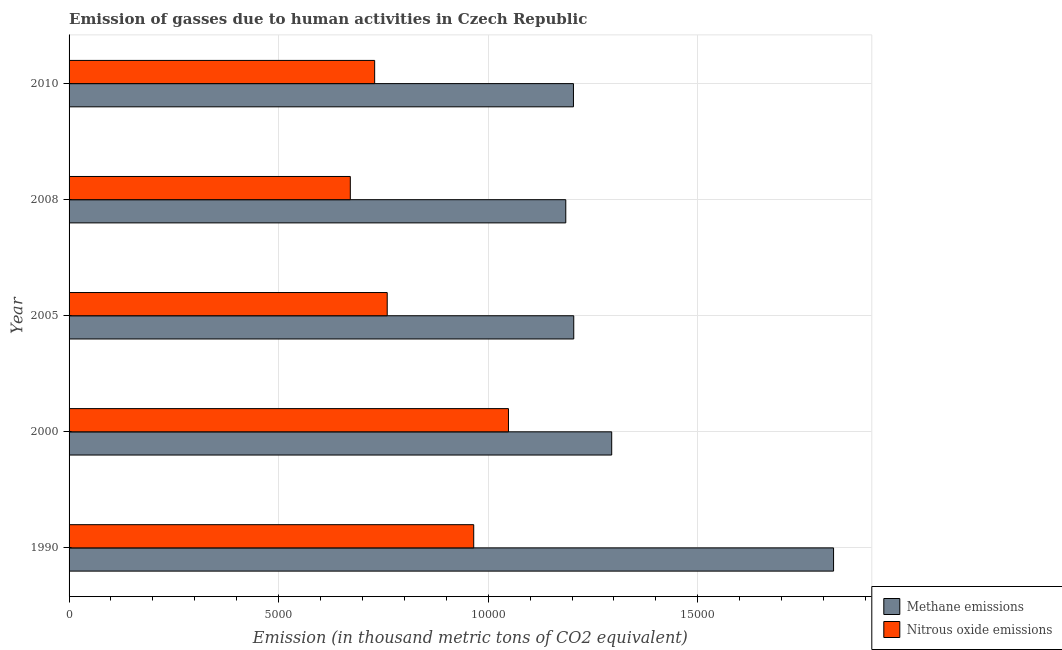Are the number of bars per tick equal to the number of legend labels?
Your answer should be compact. Yes. How many bars are there on the 1st tick from the bottom?
Give a very brief answer. 2. In how many cases, is the number of bars for a given year not equal to the number of legend labels?
Offer a very short reply. 0. What is the amount of nitrous oxide emissions in 2000?
Keep it short and to the point. 1.05e+04. Across all years, what is the maximum amount of methane emissions?
Give a very brief answer. 1.82e+04. Across all years, what is the minimum amount of methane emissions?
Offer a very short reply. 1.19e+04. In which year was the amount of methane emissions maximum?
Ensure brevity in your answer.  1990. What is the total amount of nitrous oxide emissions in the graph?
Provide a short and direct response. 4.17e+04. What is the difference between the amount of nitrous oxide emissions in 1990 and that in 2005?
Your answer should be compact. 2063.7. What is the difference between the amount of methane emissions in 2008 and the amount of nitrous oxide emissions in 2010?
Provide a short and direct response. 4559.9. What is the average amount of methane emissions per year?
Your answer should be very brief. 1.34e+04. In the year 2010, what is the difference between the amount of methane emissions and amount of nitrous oxide emissions?
Your answer should be compact. 4742.9. What is the ratio of the amount of methane emissions in 1990 to that in 2010?
Provide a short and direct response. 1.52. Is the amount of nitrous oxide emissions in 2005 less than that in 2008?
Your response must be concise. No. What is the difference between the highest and the second highest amount of methane emissions?
Provide a succinct answer. 5293.1. What is the difference between the highest and the lowest amount of methane emissions?
Provide a short and direct response. 6388.9. In how many years, is the amount of methane emissions greater than the average amount of methane emissions taken over all years?
Give a very brief answer. 1. Is the sum of the amount of methane emissions in 2000 and 2005 greater than the maximum amount of nitrous oxide emissions across all years?
Your answer should be very brief. Yes. What does the 1st bar from the top in 2005 represents?
Your answer should be very brief. Nitrous oxide emissions. What does the 2nd bar from the bottom in 2005 represents?
Offer a terse response. Nitrous oxide emissions. How many bars are there?
Ensure brevity in your answer.  10. Are all the bars in the graph horizontal?
Your answer should be compact. Yes. Does the graph contain any zero values?
Your answer should be very brief. No. Does the graph contain grids?
Give a very brief answer. Yes. How many legend labels are there?
Keep it short and to the point. 2. What is the title of the graph?
Offer a very short reply. Emission of gasses due to human activities in Czech Republic. What is the label or title of the X-axis?
Your answer should be compact. Emission (in thousand metric tons of CO2 equivalent). What is the Emission (in thousand metric tons of CO2 equivalent) of Methane emissions in 1990?
Give a very brief answer. 1.82e+04. What is the Emission (in thousand metric tons of CO2 equivalent) in Nitrous oxide emissions in 1990?
Give a very brief answer. 9654. What is the Emission (in thousand metric tons of CO2 equivalent) in Methane emissions in 2000?
Your answer should be compact. 1.29e+04. What is the Emission (in thousand metric tons of CO2 equivalent) in Nitrous oxide emissions in 2000?
Offer a very short reply. 1.05e+04. What is the Emission (in thousand metric tons of CO2 equivalent) of Methane emissions in 2005?
Offer a very short reply. 1.20e+04. What is the Emission (in thousand metric tons of CO2 equivalent) in Nitrous oxide emissions in 2005?
Provide a succinct answer. 7590.3. What is the Emission (in thousand metric tons of CO2 equivalent) of Methane emissions in 2008?
Keep it short and to the point. 1.19e+04. What is the Emission (in thousand metric tons of CO2 equivalent) of Nitrous oxide emissions in 2008?
Offer a terse response. 6709.7. What is the Emission (in thousand metric tons of CO2 equivalent) in Methane emissions in 2010?
Offer a terse response. 1.20e+04. What is the Emission (in thousand metric tons of CO2 equivalent) of Nitrous oxide emissions in 2010?
Offer a very short reply. 7290.5. Across all years, what is the maximum Emission (in thousand metric tons of CO2 equivalent) of Methane emissions?
Provide a succinct answer. 1.82e+04. Across all years, what is the maximum Emission (in thousand metric tons of CO2 equivalent) of Nitrous oxide emissions?
Keep it short and to the point. 1.05e+04. Across all years, what is the minimum Emission (in thousand metric tons of CO2 equivalent) of Methane emissions?
Provide a succinct answer. 1.19e+04. Across all years, what is the minimum Emission (in thousand metric tons of CO2 equivalent) in Nitrous oxide emissions?
Provide a short and direct response. 6709.7. What is the total Emission (in thousand metric tons of CO2 equivalent) in Methane emissions in the graph?
Your answer should be very brief. 6.71e+04. What is the total Emission (in thousand metric tons of CO2 equivalent) in Nitrous oxide emissions in the graph?
Make the answer very short. 4.17e+04. What is the difference between the Emission (in thousand metric tons of CO2 equivalent) in Methane emissions in 1990 and that in 2000?
Make the answer very short. 5293.1. What is the difference between the Emission (in thousand metric tons of CO2 equivalent) of Nitrous oxide emissions in 1990 and that in 2000?
Keep it short and to the point. -829. What is the difference between the Emission (in thousand metric tons of CO2 equivalent) in Methane emissions in 1990 and that in 2005?
Give a very brief answer. 6198.5. What is the difference between the Emission (in thousand metric tons of CO2 equivalent) of Nitrous oxide emissions in 1990 and that in 2005?
Ensure brevity in your answer.  2063.7. What is the difference between the Emission (in thousand metric tons of CO2 equivalent) in Methane emissions in 1990 and that in 2008?
Keep it short and to the point. 6388.9. What is the difference between the Emission (in thousand metric tons of CO2 equivalent) in Nitrous oxide emissions in 1990 and that in 2008?
Provide a succinct answer. 2944.3. What is the difference between the Emission (in thousand metric tons of CO2 equivalent) of Methane emissions in 1990 and that in 2010?
Your answer should be compact. 6205.9. What is the difference between the Emission (in thousand metric tons of CO2 equivalent) of Nitrous oxide emissions in 1990 and that in 2010?
Your response must be concise. 2363.5. What is the difference between the Emission (in thousand metric tons of CO2 equivalent) of Methane emissions in 2000 and that in 2005?
Provide a succinct answer. 905.4. What is the difference between the Emission (in thousand metric tons of CO2 equivalent) of Nitrous oxide emissions in 2000 and that in 2005?
Keep it short and to the point. 2892.7. What is the difference between the Emission (in thousand metric tons of CO2 equivalent) of Methane emissions in 2000 and that in 2008?
Keep it short and to the point. 1095.8. What is the difference between the Emission (in thousand metric tons of CO2 equivalent) in Nitrous oxide emissions in 2000 and that in 2008?
Offer a very short reply. 3773.3. What is the difference between the Emission (in thousand metric tons of CO2 equivalent) of Methane emissions in 2000 and that in 2010?
Offer a very short reply. 912.8. What is the difference between the Emission (in thousand metric tons of CO2 equivalent) in Nitrous oxide emissions in 2000 and that in 2010?
Your response must be concise. 3192.5. What is the difference between the Emission (in thousand metric tons of CO2 equivalent) of Methane emissions in 2005 and that in 2008?
Provide a short and direct response. 190.4. What is the difference between the Emission (in thousand metric tons of CO2 equivalent) of Nitrous oxide emissions in 2005 and that in 2008?
Your answer should be compact. 880.6. What is the difference between the Emission (in thousand metric tons of CO2 equivalent) of Methane emissions in 2005 and that in 2010?
Give a very brief answer. 7.4. What is the difference between the Emission (in thousand metric tons of CO2 equivalent) of Nitrous oxide emissions in 2005 and that in 2010?
Ensure brevity in your answer.  299.8. What is the difference between the Emission (in thousand metric tons of CO2 equivalent) in Methane emissions in 2008 and that in 2010?
Your response must be concise. -183. What is the difference between the Emission (in thousand metric tons of CO2 equivalent) in Nitrous oxide emissions in 2008 and that in 2010?
Ensure brevity in your answer.  -580.8. What is the difference between the Emission (in thousand metric tons of CO2 equivalent) in Methane emissions in 1990 and the Emission (in thousand metric tons of CO2 equivalent) in Nitrous oxide emissions in 2000?
Give a very brief answer. 7756.3. What is the difference between the Emission (in thousand metric tons of CO2 equivalent) of Methane emissions in 1990 and the Emission (in thousand metric tons of CO2 equivalent) of Nitrous oxide emissions in 2005?
Your answer should be very brief. 1.06e+04. What is the difference between the Emission (in thousand metric tons of CO2 equivalent) of Methane emissions in 1990 and the Emission (in thousand metric tons of CO2 equivalent) of Nitrous oxide emissions in 2008?
Your answer should be compact. 1.15e+04. What is the difference between the Emission (in thousand metric tons of CO2 equivalent) of Methane emissions in 1990 and the Emission (in thousand metric tons of CO2 equivalent) of Nitrous oxide emissions in 2010?
Make the answer very short. 1.09e+04. What is the difference between the Emission (in thousand metric tons of CO2 equivalent) of Methane emissions in 2000 and the Emission (in thousand metric tons of CO2 equivalent) of Nitrous oxide emissions in 2005?
Ensure brevity in your answer.  5355.9. What is the difference between the Emission (in thousand metric tons of CO2 equivalent) of Methane emissions in 2000 and the Emission (in thousand metric tons of CO2 equivalent) of Nitrous oxide emissions in 2008?
Your response must be concise. 6236.5. What is the difference between the Emission (in thousand metric tons of CO2 equivalent) of Methane emissions in 2000 and the Emission (in thousand metric tons of CO2 equivalent) of Nitrous oxide emissions in 2010?
Make the answer very short. 5655.7. What is the difference between the Emission (in thousand metric tons of CO2 equivalent) of Methane emissions in 2005 and the Emission (in thousand metric tons of CO2 equivalent) of Nitrous oxide emissions in 2008?
Offer a very short reply. 5331.1. What is the difference between the Emission (in thousand metric tons of CO2 equivalent) of Methane emissions in 2005 and the Emission (in thousand metric tons of CO2 equivalent) of Nitrous oxide emissions in 2010?
Your answer should be very brief. 4750.3. What is the difference between the Emission (in thousand metric tons of CO2 equivalent) of Methane emissions in 2008 and the Emission (in thousand metric tons of CO2 equivalent) of Nitrous oxide emissions in 2010?
Your answer should be compact. 4559.9. What is the average Emission (in thousand metric tons of CO2 equivalent) of Methane emissions per year?
Ensure brevity in your answer.  1.34e+04. What is the average Emission (in thousand metric tons of CO2 equivalent) in Nitrous oxide emissions per year?
Provide a succinct answer. 8345.5. In the year 1990, what is the difference between the Emission (in thousand metric tons of CO2 equivalent) of Methane emissions and Emission (in thousand metric tons of CO2 equivalent) of Nitrous oxide emissions?
Ensure brevity in your answer.  8585.3. In the year 2000, what is the difference between the Emission (in thousand metric tons of CO2 equivalent) of Methane emissions and Emission (in thousand metric tons of CO2 equivalent) of Nitrous oxide emissions?
Give a very brief answer. 2463.2. In the year 2005, what is the difference between the Emission (in thousand metric tons of CO2 equivalent) in Methane emissions and Emission (in thousand metric tons of CO2 equivalent) in Nitrous oxide emissions?
Your answer should be compact. 4450.5. In the year 2008, what is the difference between the Emission (in thousand metric tons of CO2 equivalent) in Methane emissions and Emission (in thousand metric tons of CO2 equivalent) in Nitrous oxide emissions?
Provide a succinct answer. 5140.7. In the year 2010, what is the difference between the Emission (in thousand metric tons of CO2 equivalent) of Methane emissions and Emission (in thousand metric tons of CO2 equivalent) of Nitrous oxide emissions?
Make the answer very short. 4742.9. What is the ratio of the Emission (in thousand metric tons of CO2 equivalent) of Methane emissions in 1990 to that in 2000?
Provide a short and direct response. 1.41. What is the ratio of the Emission (in thousand metric tons of CO2 equivalent) in Nitrous oxide emissions in 1990 to that in 2000?
Provide a succinct answer. 0.92. What is the ratio of the Emission (in thousand metric tons of CO2 equivalent) of Methane emissions in 1990 to that in 2005?
Your answer should be very brief. 1.51. What is the ratio of the Emission (in thousand metric tons of CO2 equivalent) of Nitrous oxide emissions in 1990 to that in 2005?
Give a very brief answer. 1.27. What is the ratio of the Emission (in thousand metric tons of CO2 equivalent) in Methane emissions in 1990 to that in 2008?
Offer a very short reply. 1.54. What is the ratio of the Emission (in thousand metric tons of CO2 equivalent) in Nitrous oxide emissions in 1990 to that in 2008?
Provide a succinct answer. 1.44. What is the ratio of the Emission (in thousand metric tons of CO2 equivalent) in Methane emissions in 1990 to that in 2010?
Give a very brief answer. 1.52. What is the ratio of the Emission (in thousand metric tons of CO2 equivalent) in Nitrous oxide emissions in 1990 to that in 2010?
Provide a short and direct response. 1.32. What is the ratio of the Emission (in thousand metric tons of CO2 equivalent) in Methane emissions in 2000 to that in 2005?
Your answer should be compact. 1.08. What is the ratio of the Emission (in thousand metric tons of CO2 equivalent) in Nitrous oxide emissions in 2000 to that in 2005?
Provide a short and direct response. 1.38. What is the ratio of the Emission (in thousand metric tons of CO2 equivalent) of Methane emissions in 2000 to that in 2008?
Offer a very short reply. 1.09. What is the ratio of the Emission (in thousand metric tons of CO2 equivalent) in Nitrous oxide emissions in 2000 to that in 2008?
Provide a short and direct response. 1.56. What is the ratio of the Emission (in thousand metric tons of CO2 equivalent) in Methane emissions in 2000 to that in 2010?
Give a very brief answer. 1.08. What is the ratio of the Emission (in thousand metric tons of CO2 equivalent) of Nitrous oxide emissions in 2000 to that in 2010?
Offer a very short reply. 1.44. What is the ratio of the Emission (in thousand metric tons of CO2 equivalent) in Methane emissions in 2005 to that in 2008?
Give a very brief answer. 1.02. What is the ratio of the Emission (in thousand metric tons of CO2 equivalent) of Nitrous oxide emissions in 2005 to that in 2008?
Keep it short and to the point. 1.13. What is the ratio of the Emission (in thousand metric tons of CO2 equivalent) of Nitrous oxide emissions in 2005 to that in 2010?
Offer a terse response. 1.04. What is the ratio of the Emission (in thousand metric tons of CO2 equivalent) of Nitrous oxide emissions in 2008 to that in 2010?
Offer a very short reply. 0.92. What is the difference between the highest and the second highest Emission (in thousand metric tons of CO2 equivalent) of Methane emissions?
Ensure brevity in your answer.  5293.1. What is the difference between the highest and the second highest Emission (in thousand metric tons of CO2 equivalent) in Nitrous oxide emissions?
Offer a terse response. 829. What is the difference between the highest and the lowest Emission (in thousand metric tons of CO2 equivalent) of Methane emissions?
Provide a succinct answer. 6388.9. What is the difference between the highest and the lowest Emission (in thousand metric tons of CO2 equivalent) in Nitrous oxide emissions?
Ensure brevity in your answer.  3773.3. 